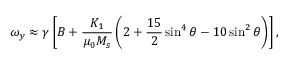Convert formula to latex. <formula><loc_0><loc_0><loc_500><loc_500>\omega _ { y } \approx \gamma \left [ B + \frac { K _ { 1 } } { \mu _ { 0 } M _ { s } } \left ( 2 + \frac { 1 5 } { 2 } \sin ^ { 4 } \theta - 1 0 \sin ^ { 2 } \theta \right ) \right ] ,</formula> 